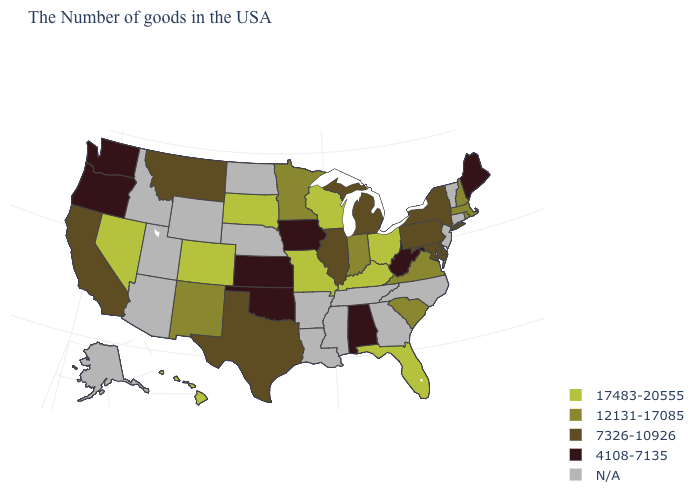Among the states that border New Jersey , which have the highest value?
Write a very short answer. New York, Delaware, Pennsylvania. What is the value of Missouri?
Answer briefly. 17483-20555. Among the states that border Maryland , which have the lowest value?
Write a very short answer. West Virginia. Does the map have missing data?
Concise answer only. Yes. What is the value of South Carolina?
Answer briefly. 12131-17085. Name the states that have a value in the range 17483-20555?
Write a very short answer. Ohio, Florida, Kentucky, Wisconsin, Missouri, South Dakota, Colorado, Nevada, Hawaii. What is the highest value in states that border North Carolina?
Short answer required. 12131-17085. Among the states that border New Hampshire , does Maine have the highest value?
Be succinct. No. What is the value of Kansas?
Quick response, please. 4108-7135. What is the highest value in states that border Utah?
Give a very brief answer. 17483-20555. Name the states that have a value in the range 12131-17085?
Short answer required. Massachusetts, Rhode Island, New Hampshire, Virginia, South Carolina, Indiana, Minnesota, New Mexico. Does the map have missing data?
Keep it brief. Yes. Which states have the lowest value in the USA?
Quick response, please. Maine, West Virginia, Alabama, Iowa, Kansas, Oklahoma, Washington, Oregon. What is the value of New Jersey?
Concise answer only. N/A. 